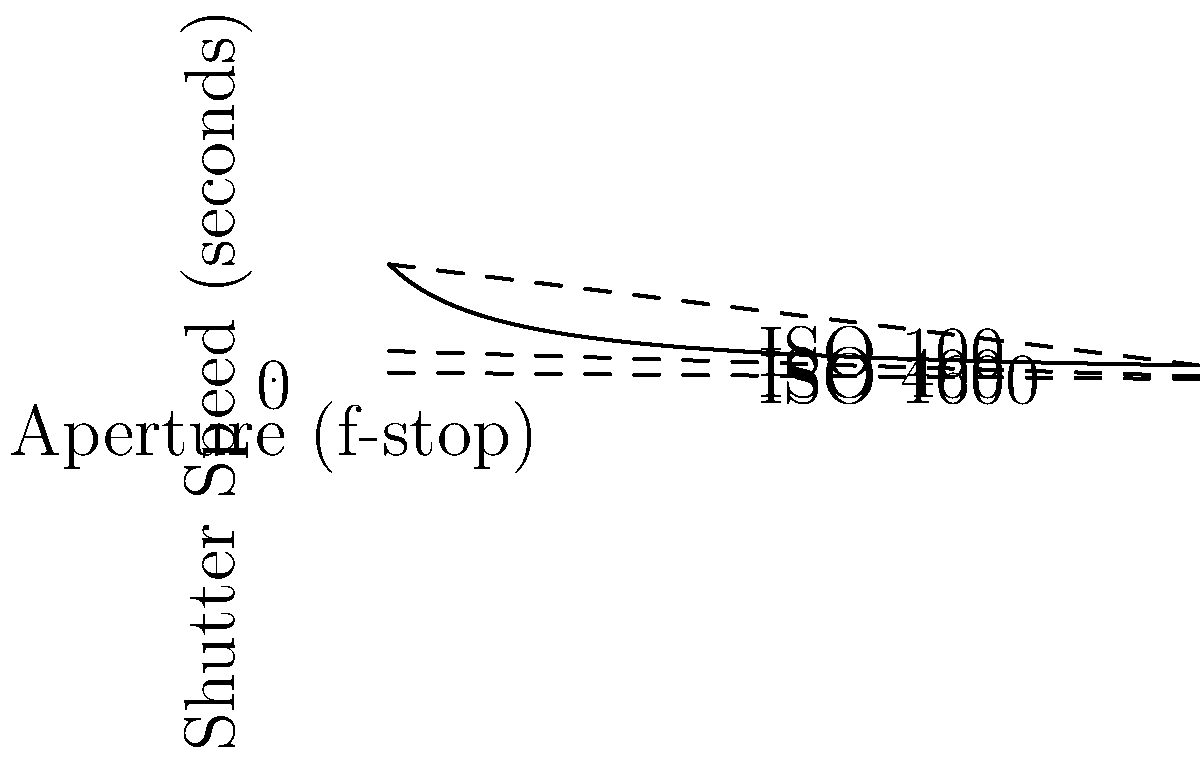Given the relationship between aperture, shutter speed, and ISO shown in the graph, what combination of settings would you choose to photograph a rare nocturnal lemur in a dimly lit forest, prioritizing image quality while maintaining a shutter speed of at least 1/15 second to avoid motion blur? To answer this question, we need to consider the following steps:

1. Understand the graph:
   - The x-axis represents aperture (f-stop), where lower numbers mean a wider aperture.
   - The y-axis represents shutter speed in seconds.
   - The curves represent different ISO settings (100, 400, 1600).

2. Consider the constraints:
   - We need a shutter speed of at least 1/15 second (approximately 0.067 seconds) to avoid motion blur.
   - We want to prioritize image quality, which means using the lowest possible ISO.

3. Analyze the options:
   - Starting with the lowest ISO (100), we can see that to achieve a 1/15 second shutter speed, we would need an aperture wider than f/1, which is not practical for most lenses.
   - Moving to ISO 400, we can achieve 1/15 second with an aperture of about f/2.8, which is more reasonable.
   - At ISO 1600, we could use an even smaller aperture, but this would compromise image quality due to increased noise.

4. Choose the optimal settings:
   - ISO 400 provides a good balance between low light performance and image quality.
   - With ISO 400, we can use an aperture of f/2.8 and a shutter speed of 1/15 second.

5. Fine-tuning:
   - If possible, we might slightly increase the aperture to f/2 or f/2.2 to allow for a faster shutter speed, further reducing the risk of motion blur.

Therefore, the optimal combination would be:
- Aperture: f/2.8 (or slightly wider if possible)
- Shutter speed: 1/15 second (or slightly faster)
- ISO: 400
Answer: f/2.8, 1/15 s, ISO 400 